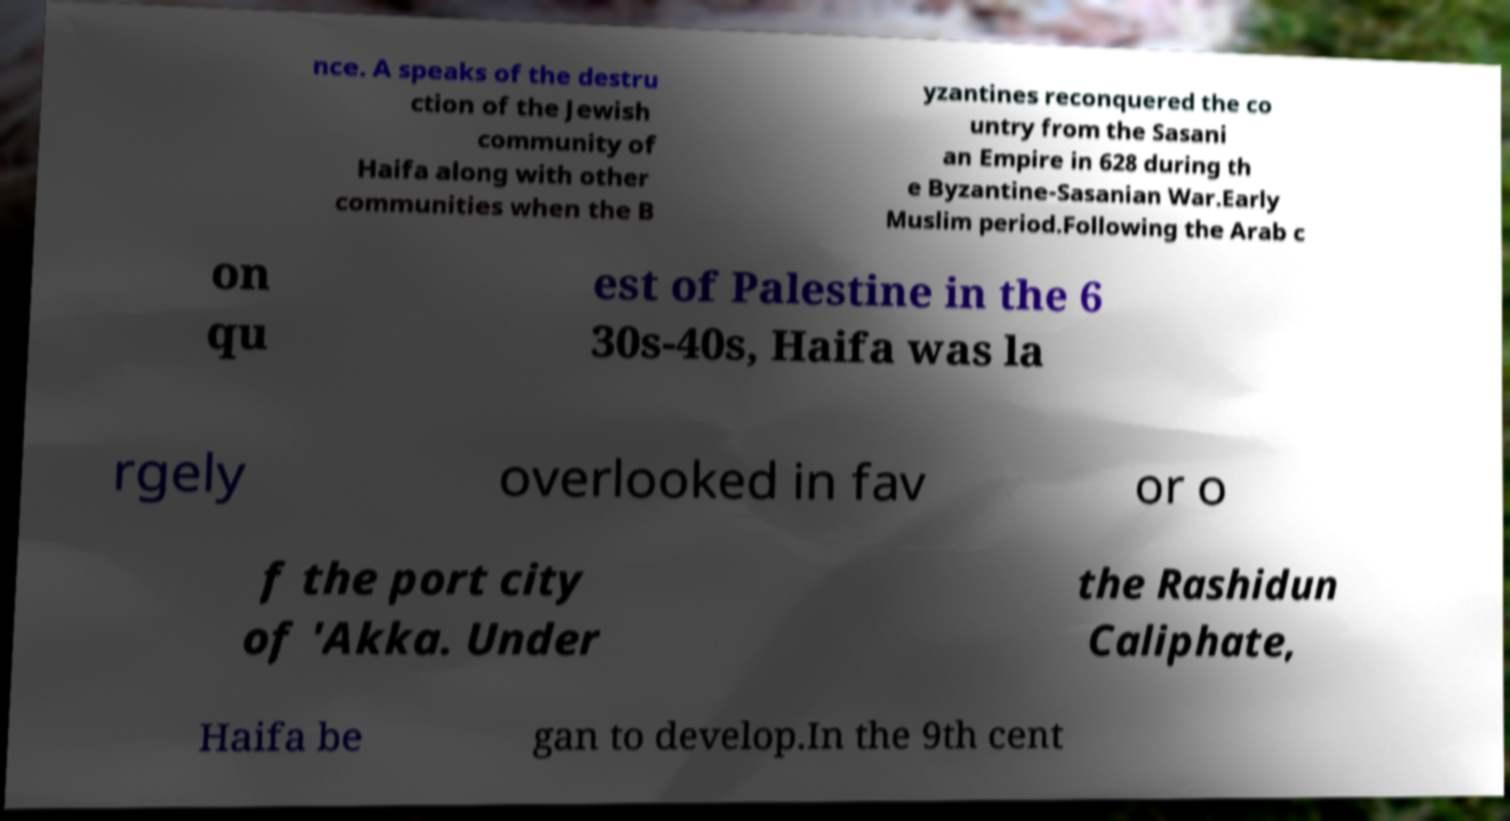Could you assist in decoding the text presented in this image and type it out clearly? nce. A speaks of the destru ction of the Jewish community of Haifa along with other communities when the B yzantines reconquered the co untry from the Sasani an Empire in 628 during th e Byzantine-Sasanian War.Early Muslim period.Following the Arab c on qu est of Palestine in the 6 30s-40s, Haifa was la rgely overlooked in fav or o f the port city of 'Akka. Under the Rashidun Caliphate, Haifa be gan to develop.In the 9th cent 